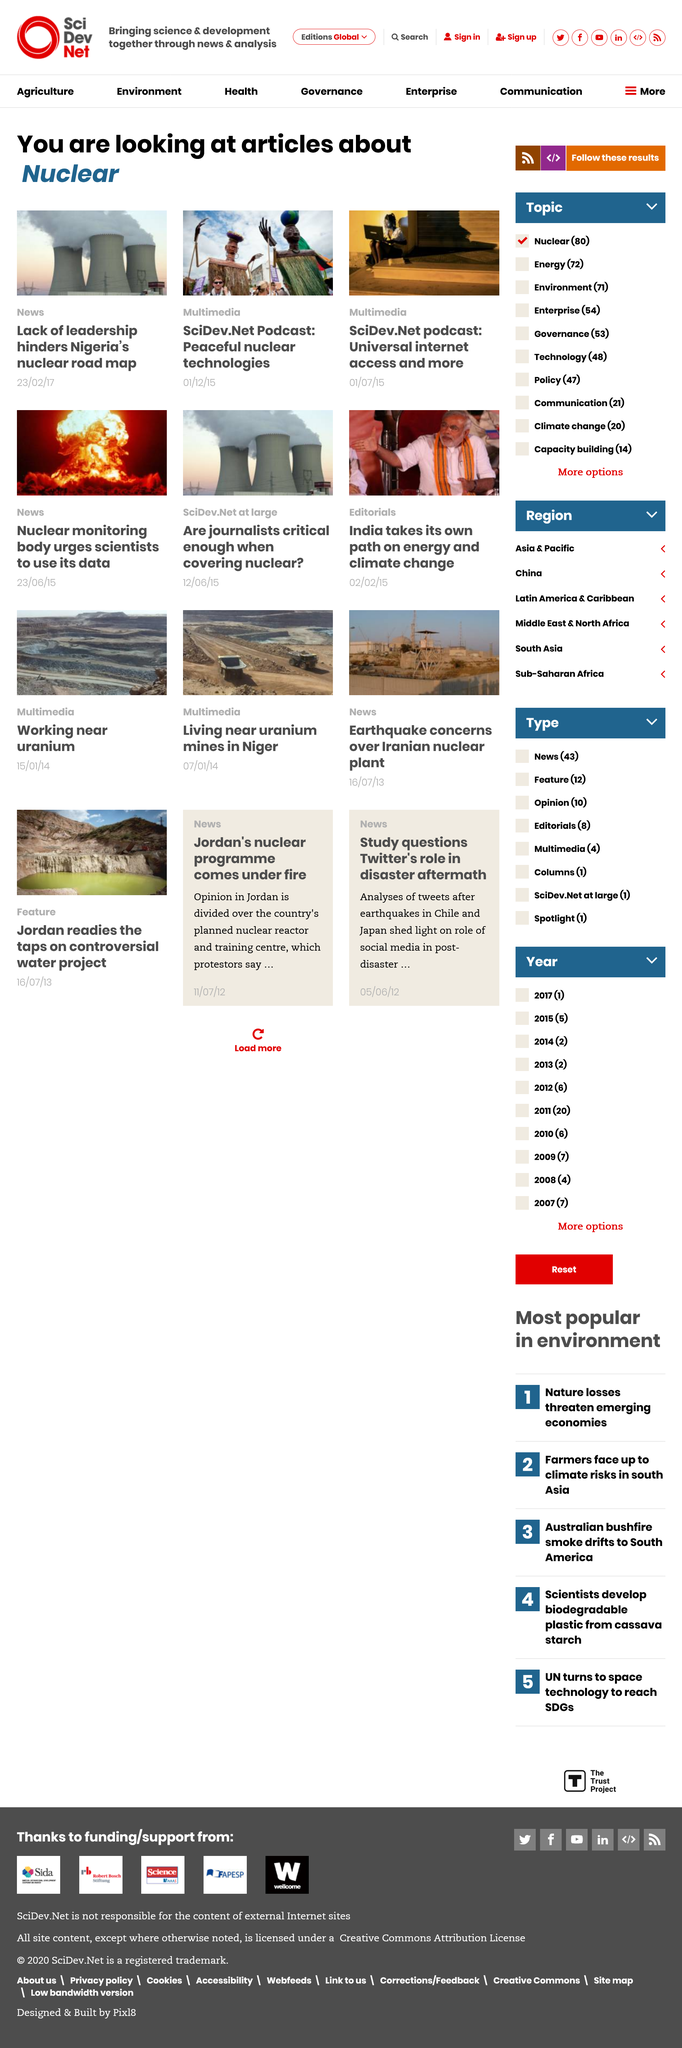Outline some significant characteristics in this image. Yes, peaceful nuclear technologies are the subject of one of the SciDev.Net podcasts. The article on the lack of leadership in Nigeria falls under the News category. Nigeria's nuclear road map has been hindered by a lack of leadership. 